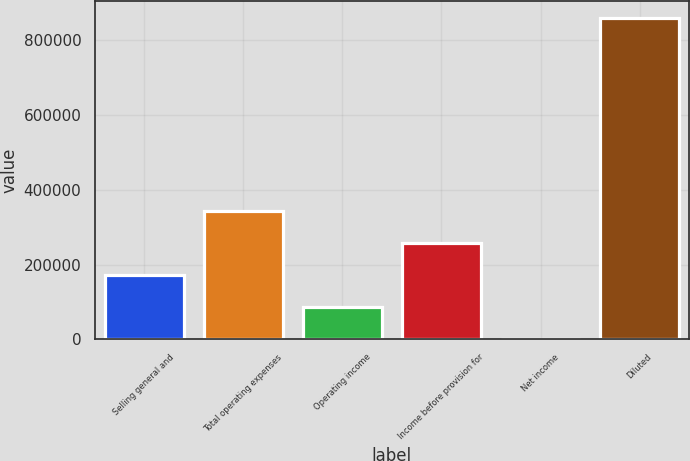Convert chart. <chart><loc_0><loc_0><loc_500><loc_500><bar_chart><fcel>Selling general and<fcel>Total operating expenses<fcel>Operating income<fcel>Income before provision for<fcel>Net income<fcel>Diluted<nl><fcel>172394<fcel>344467<fcel>86356.8<fcel>258430<fcel>320<fcel>860688<nl></chart> 